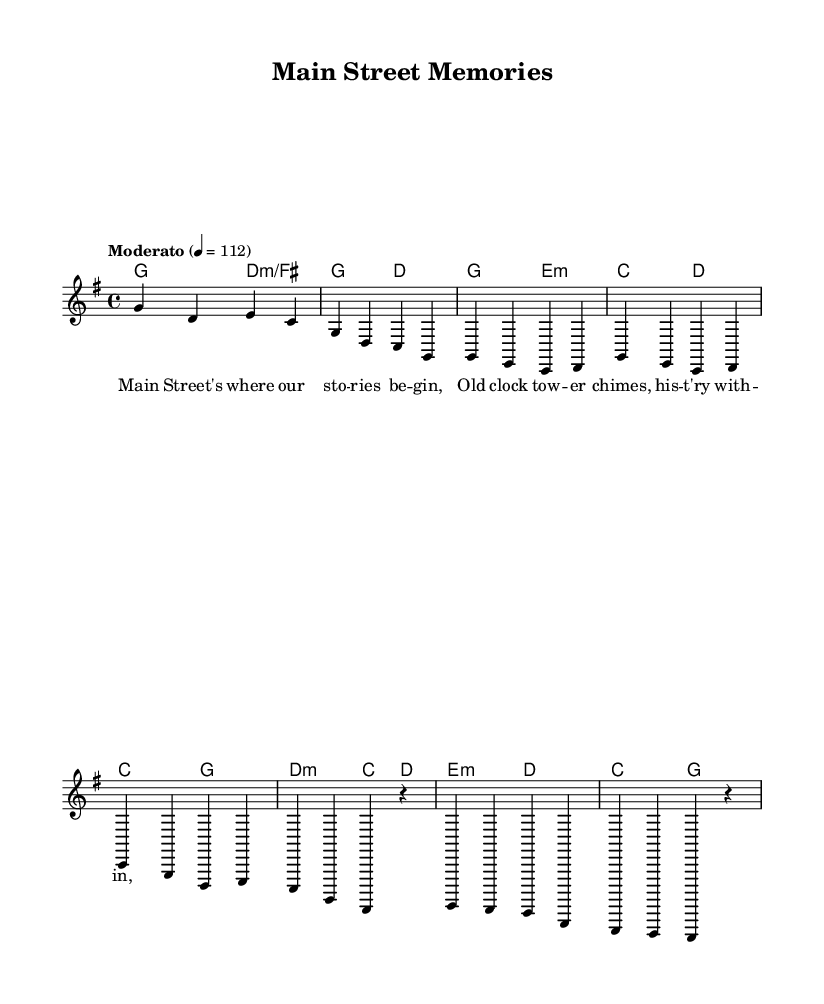What is the key signature of this music? The key signature is G major, indicated by one sharp.
Answer: G major What is the time signature of this music? The time signature is 4/4, which means there are four beats in each measure.
Answer: 4/4 What is the tempo marking for this music? The tempo marking is Moderato, indicating a moderate pace, typically around 108 to 120 beats per minute.
Answer: Moderato What are the first two notes of the melody? The first two notes are G and D, as seen in the measure where the melody starts.
Answer: G, D How many measures are in the given melody? The melody comprises a total of 8 measures as counted from the beginning to the end of the provided segment.
Answer: 8 measures What lyrical theme is presented in the verse? The verse speaks about memories associated with Main Street, focusing on stories and history.
Answer: Main Street's stories Which chord appears at the start of the chorus? The chord that appears at the start of the chorus is C major, as indicated in the chord progression.
Answer: C major 